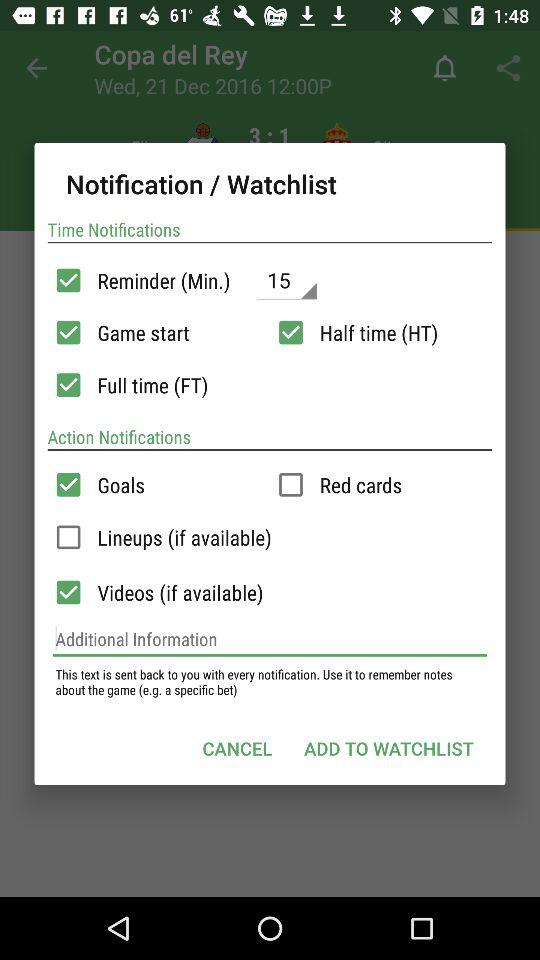What is the status of "Goals" in action notifications? The status is "on". 